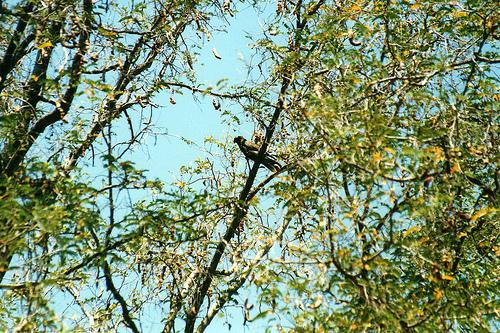Question: where was this picture taken?
Choices:
A. At the beach.
B. In the woods.
C. At the mall.
D. At the zoo.
Answer with the letter. Answer: B Question: how many birds are in this photo?
Choices:
A. Two.
B. Three.
C. One.
D. Four.
Answer with the letter. Answer: C Question: what color is the sky?
Choices:
A. Blue.
B. Grey.
C. Orange.
D. Black.
Answer with the letter. Answer: A Question: what color are the leaves on the trees?
Choices:
A. Green.
B. Red.
C. Yellow.
D. Brown.
Answer with the letter. Answer: A Question: what is the weather in the photo?
Choices:
A. Cloudy.
B. Rainy.
C. Sunny.
D. Snowy.
Answer with the letter. Answer: C 